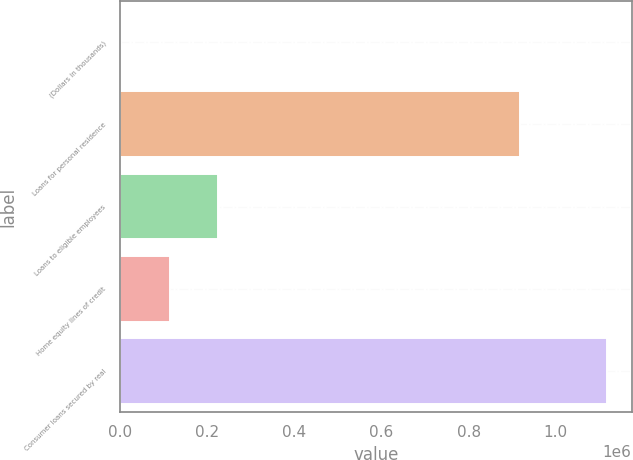<chart> <loc_0><loc_0><loc_500><loc_500><bar_chart><fcel>(Dollars in thousands)<fcel>Loans for personal residence<fcel>Loans to eligible employees<fcel>Home equity lines of credit<fcel>Consumer loans secured by real<nl><fcel>2014<fcel>918629<fcel>225234<fcel>113624<fcel>1.11812e+06<nl></chart> 